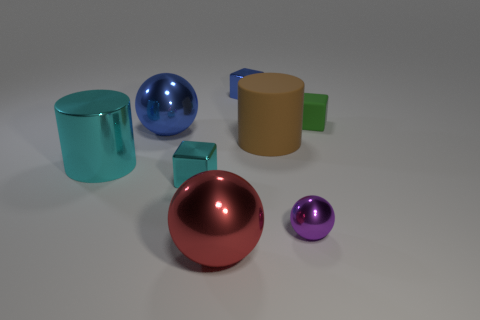What number of small blue cylinders are there?
Offer a very short reply. 0. What number of things are either blue metal objects or large metal objects that are in front of the big cyan shiny object?
Your response must be concise. 3. Is there any other thing that has the same shape as the small rubber object?
Offer a very short reply. Yes. Do the blue metallic object to the right of the blue metallic ball and the rubber cube have the same size?
Your answer should be compact. Yes. What number of rubber things are either small spheres or large cyan cylinders?
Keep it short and to the point. 0. What size is the cylinder left of the large red sphere?
Provide a succinct answer. Large. Does the tiny cyan metallic thing have the same shape as the green thing?
Your answer should be very brief. Yes. What number of large things are blue metal balls or matte objects?
Your answer should be very brief. 2. Are there any purple metallic things behind the large cyan cylinder?
Your answer should be very brief. No. Is the number of metallic blocks that are to the right of the purple thing the same as the number of small green rubber blocks?
Provide a short and direct response. No. 